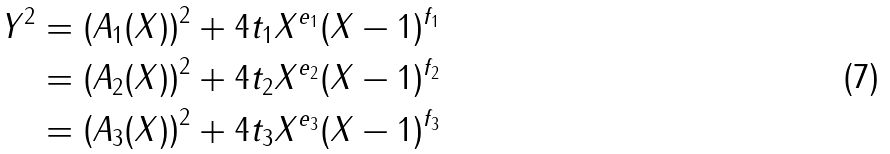Convert formula to latex. <formula><loc_0><loc_0><loc_500><loc_500>Y ^ { 2 } & = \left ( A _ { 1 } ( X ) \right ) ^ { 2 } + 4 t _ { 1 } X ^ { e _ { 1 } } ( X - 1 ) ^ { f _ { 1 } } \\ & = \left ( A _ { 2 } ( X ) \right ) ^ { 2 } + 4 t _ { 2 } X ^ { e _ { 2 } } ( X - 1 ) ^ { f _ { 2 } } \\ & = \left ( A _ { 3 } ( X ) \right ) ^ { 2 } + 4 t _ { 3 } X ^ { e _ { 3 } } ( X - 1 ) ^ { f _ { 3 } }</formula> 